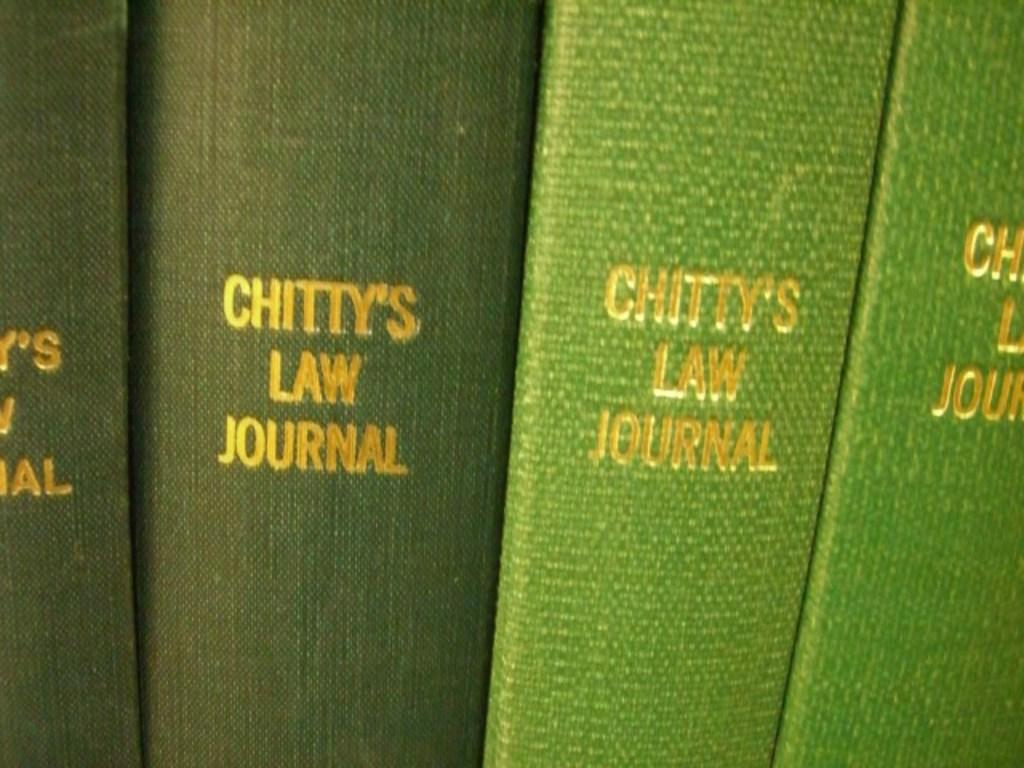<image>
Offer a succinct explanation of the picture presented. 4 green books with chitty's law journal written on spine in gold lettering 